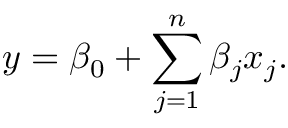Convert formula to latex. <formula><loc_0><loc_0><loc_500><loc_500>y = \beta _ { 0 } + \sum _ { j = 1 } ^ { n } \beta _ { j } x _ { j } .</formula> 